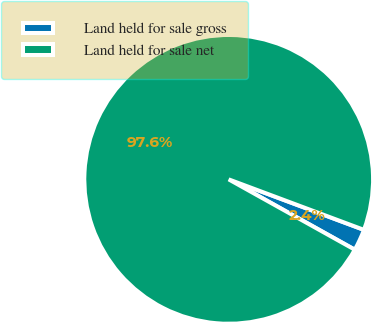Convert chart to OTSL. <chart><loc_0><loc_0><loc_500><loc_500><pie_chart><fcel>Land held for sale gross<fcel>Land held for sale net<nl><fcel>2.41%<fcel>97.59%<nl></chart> 